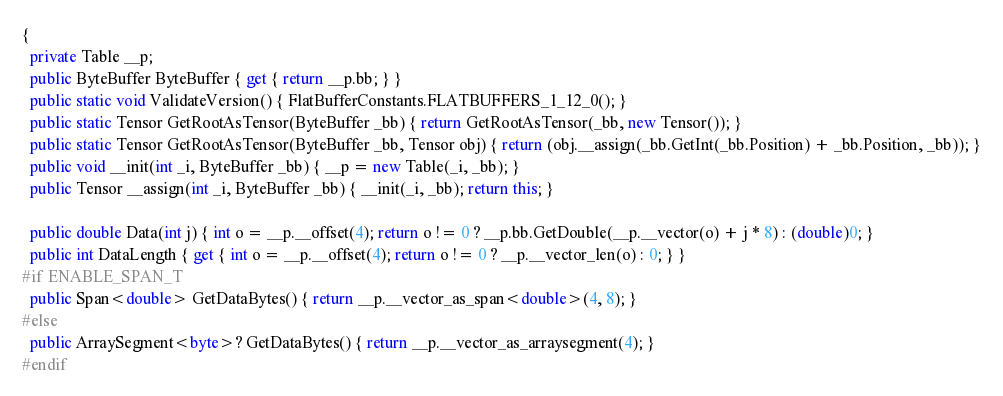<code> <loc_0><loc_0><loc_500><loc_500><_C#_>{
  private Table __p;
  public ByteBuffer ByteBuffer { get { return __p.bb; } }
  public static void ValidateVersion() { FlatBufferConstants.FLATBUFFERS_1_12_0(); }
  public static Tensor GetRootAsTensor(ByteBuffer _bb) { return GetRootAsTensor(_bb, new Tensor()); }
  public static Tensor GetRootAsTensor(ByteBuffer _bb, Tensor obj) { return (obj.__assign(_bb.GetInt(_bb.Position) + _bb.Position, _bb)); }
  public void __init(int _i, ByteBuffer _bb) { __p = new Table(_i, _bb); }
  public Tensor __assign(int _i, ByteBuffer _bb) { __init(_i, _bb); return this; }

  public double Data(int j) { int o = __p.__offset(4); return o != 0 ? __p.bb.GetDouble(__p.__vector(o) + j * 8) : (double)0; }
  public int DataLength { get { int o = __p.__offset(4); return o != 0 ? __p.__vector_len(o) : 0; } }
#if ENABLE_SPAN_T
  public Span<double> GetDataBytes() { return __p.__vector_as_span<double>(4, 8); }
#else
  public ArraySegment<byte>? GetDataBytes() { return __p.__vector_as_arraysegment(4); }
#endif</code> 